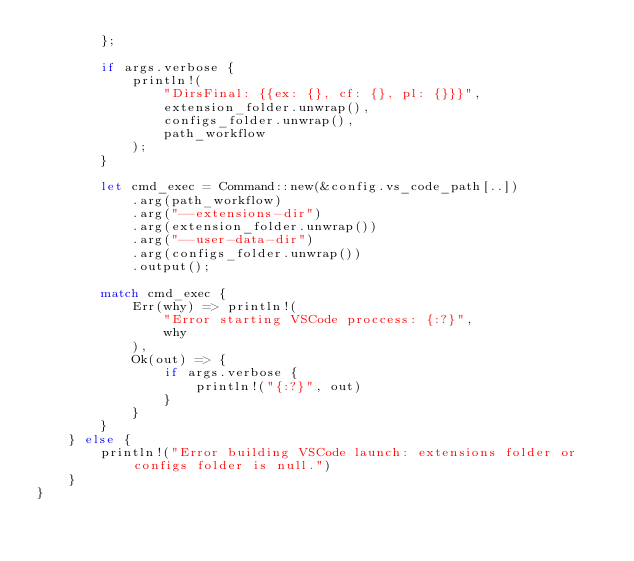Convert code to text. <code><loc_0><loc_0><loc_500><loc_500><_Rust_>        };

        if args.verbose {
            println!(
                "DirsFinal: {{ex: {}, cf: {}, pl: {}}}",
                extension_folder.unwrap(),
                configs_folder.unwrap(),
                path_workflow
            );
        }

        let cmd_exec = Command::new(&config.vs_code_path[..])
            .arg(path_workflow)
            .arg("--extensions-dir")
            .arg(extension_folder.unwrap())
            .arg("--user-data-dir")
            .arg(configs_folder.unwrap())
            .output();

        match cmd_exec {
            Err(why) => println!(
                "Error starting VSCode proccess: {:?}",
                why
            ),
            Ok(out) => {
                if args.verbose {
                    println!("{:?}", out)
                }
            }
        }
    } else {
        println!("Error building VSCode launch: extensions folder or configs folder is null.")
    }
}
</code> 